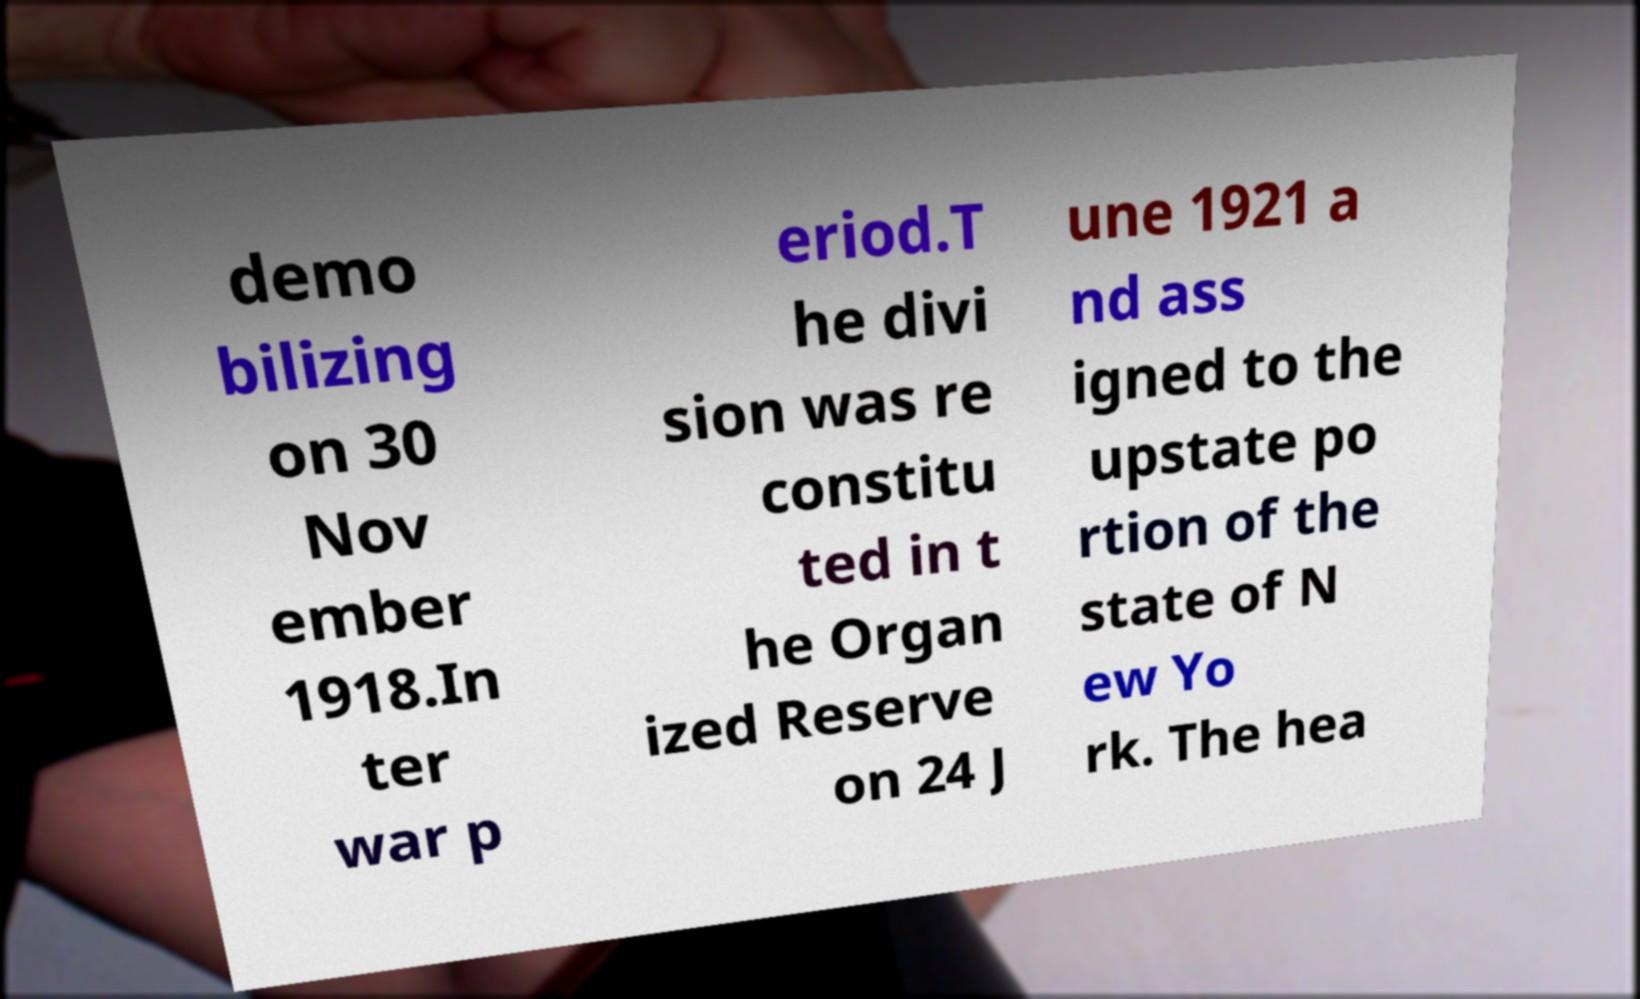Could you extract and type out the text from this image? demo bilizing on 30 Nov ember 1918.In ter war p eriod.T he divi sion was re constitu ted in t he Organ ized Reserve on 24 J une 1921 a nd ass igned to the upstate po rtion of the state of N ew Yo rk. The hea 